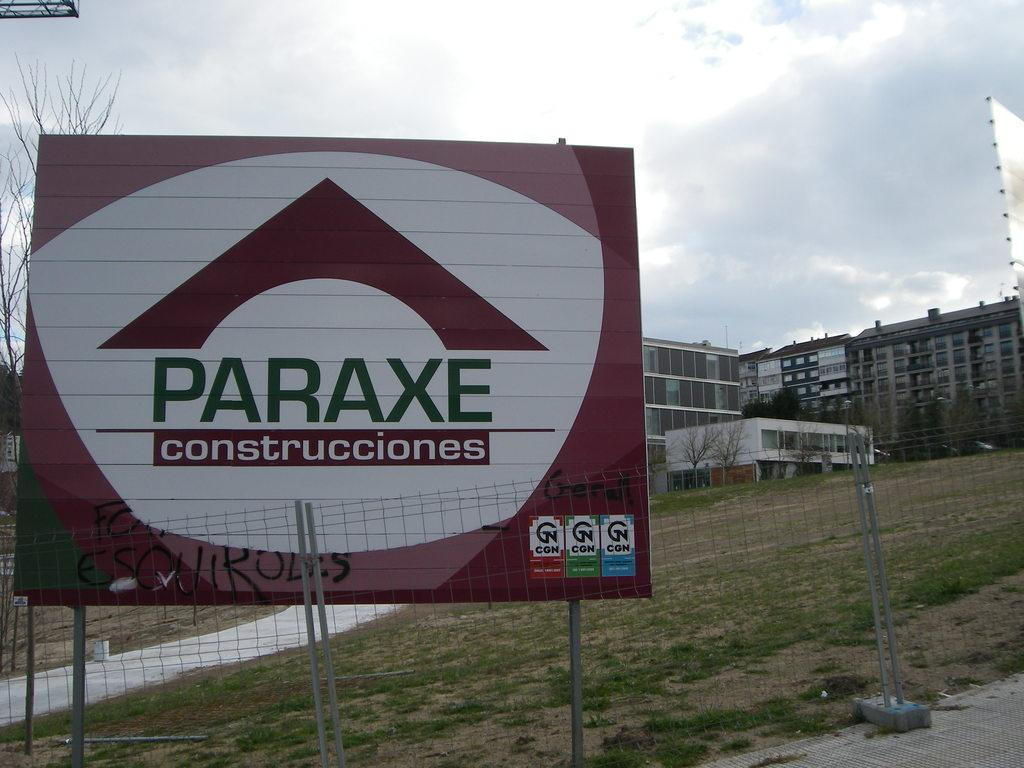<image>
Provide a brief description of the given image. A large sign for Paraxe Construcctiones against a fence. 